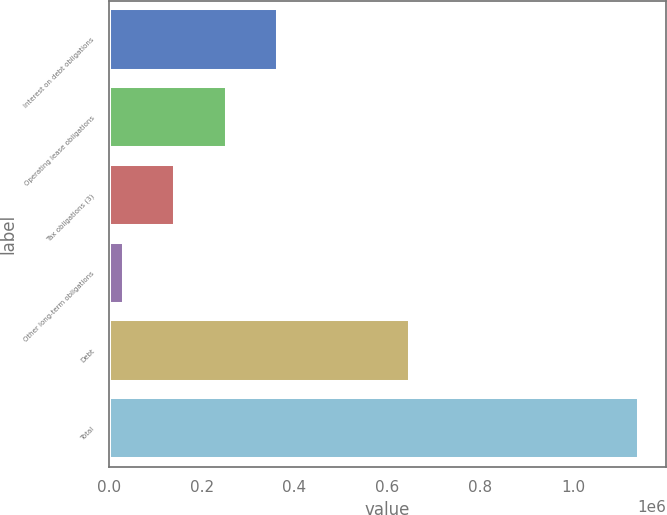<chart> <loc_0><loc_0><loc_500><loc_500><bar_chart><fcel>Interest on debt obligations<fcel>Operating lease obligations<fcel>Tax obligations (3)<fcel>Other long-term obligations<fcel>Debt<fcel>Total<nl><fcel>365409<fcel>254494<fcel>143578<fcel>32663<fcel>647500<fcel>1.14182e+06<nl></chart> 